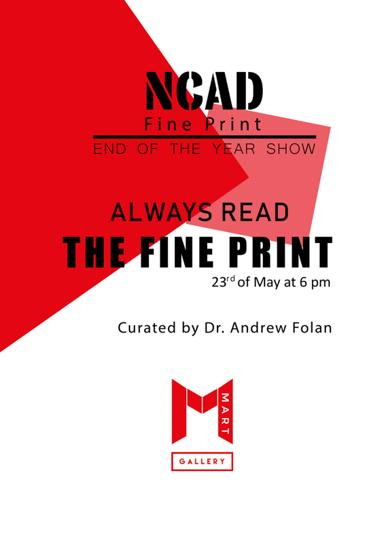What is the event mentioned in the poster? The poster advertises 'End of the Year Show - Always Read the Fine Print,' a unique art exhibition highlighting intricate print design techniques. 